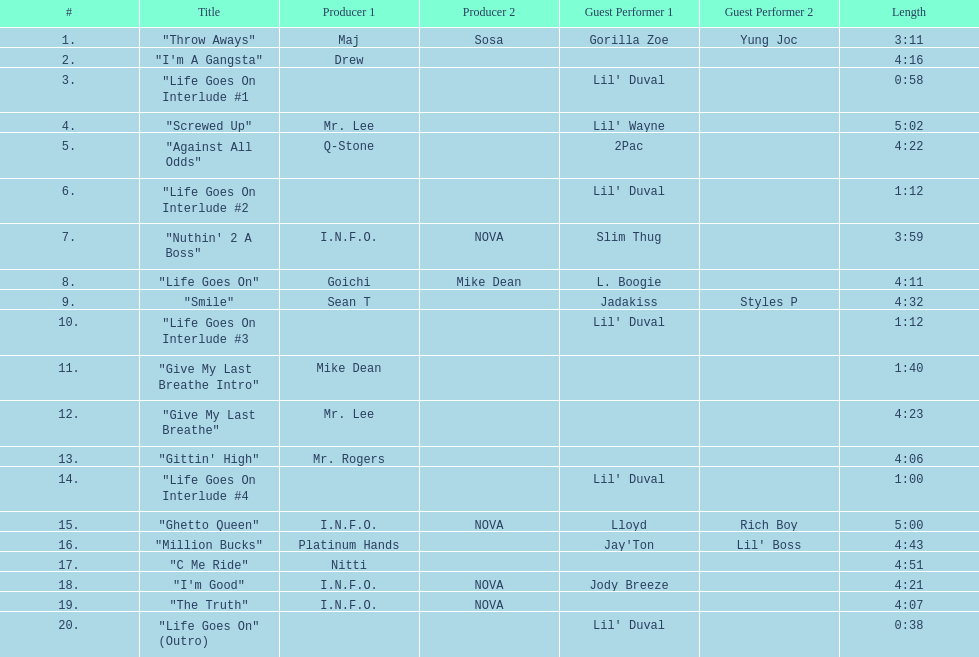Which producers produced the majority of songs on this record? I.N.F.O. & NOVA. 